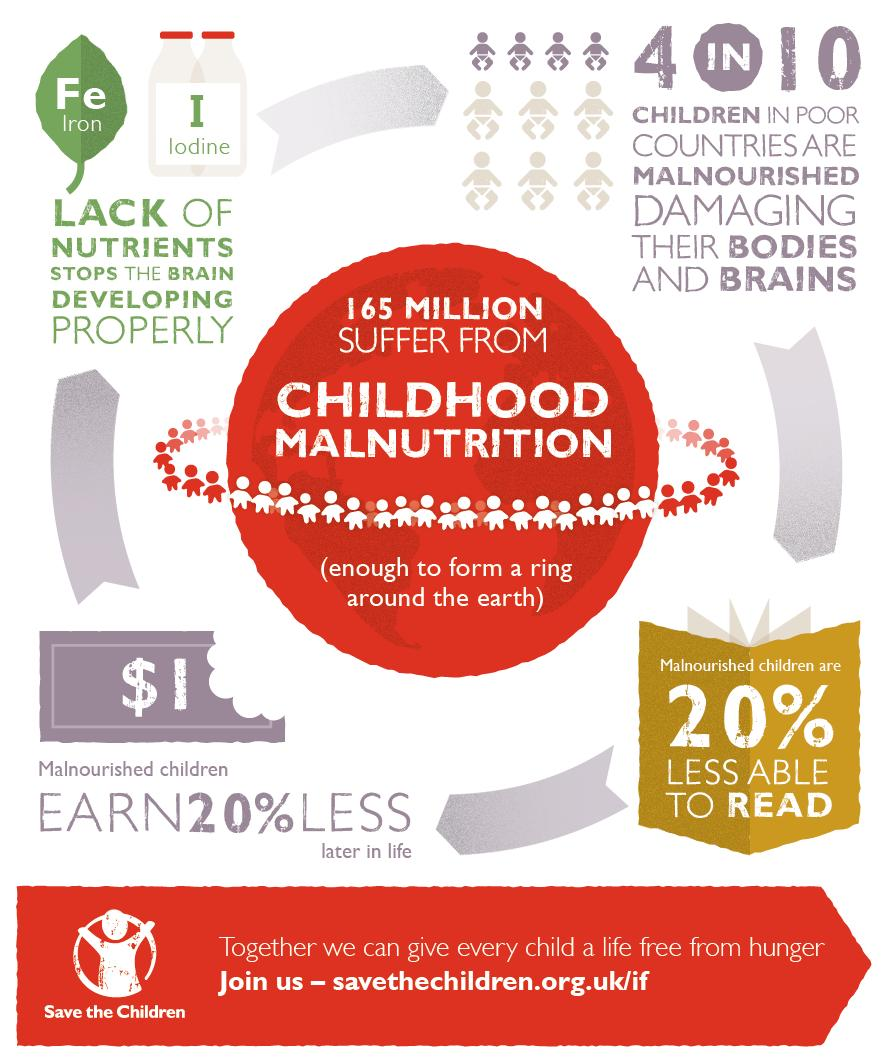Indicate a few pertinent items in this graphic. Proper brain development is hindered by a lack of essential nutrients. Malnutrition is a condition that can cause damage to the bodies and brains of children, leading to potentially serious and long-lasting consequences. The total number of children suffering from malnutrition is 165 million. The image provides the names of two nutrients, which are iron and iodine. 